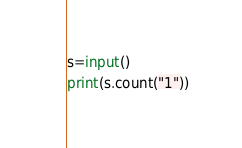Convert code to text. <code><loc_0><loc_0><loc_500><loc_500><_Python_>s=input()
print(s.count("1"))</code> 